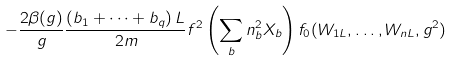<formula> <loc_0><loc_0><loc_500><loc_500>- \frac { 2 \beta ( g ) } { g } \frac { \left ( b _ { 1 } + \dots + b _ { q } \right ) L } { 2 m } f ^ { 2 } \left ( \sum _ { b } n _ { b } ^ { 2 } X _ { b } \right ) f _ { 0 } ( W _ { 1 L } , \dots , W _ { n L } , g ^ { 2 } )</formula> 